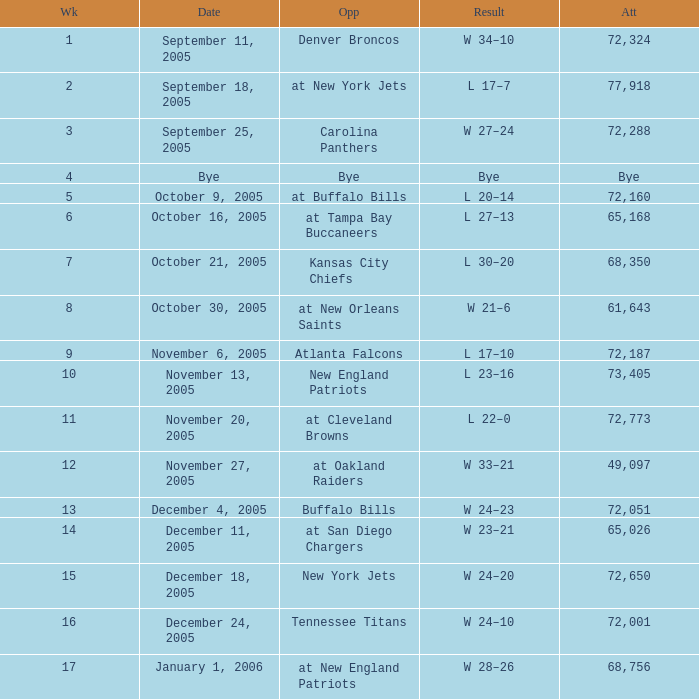Who was the Opponent on November 27, 2005? At oakland raiders. 